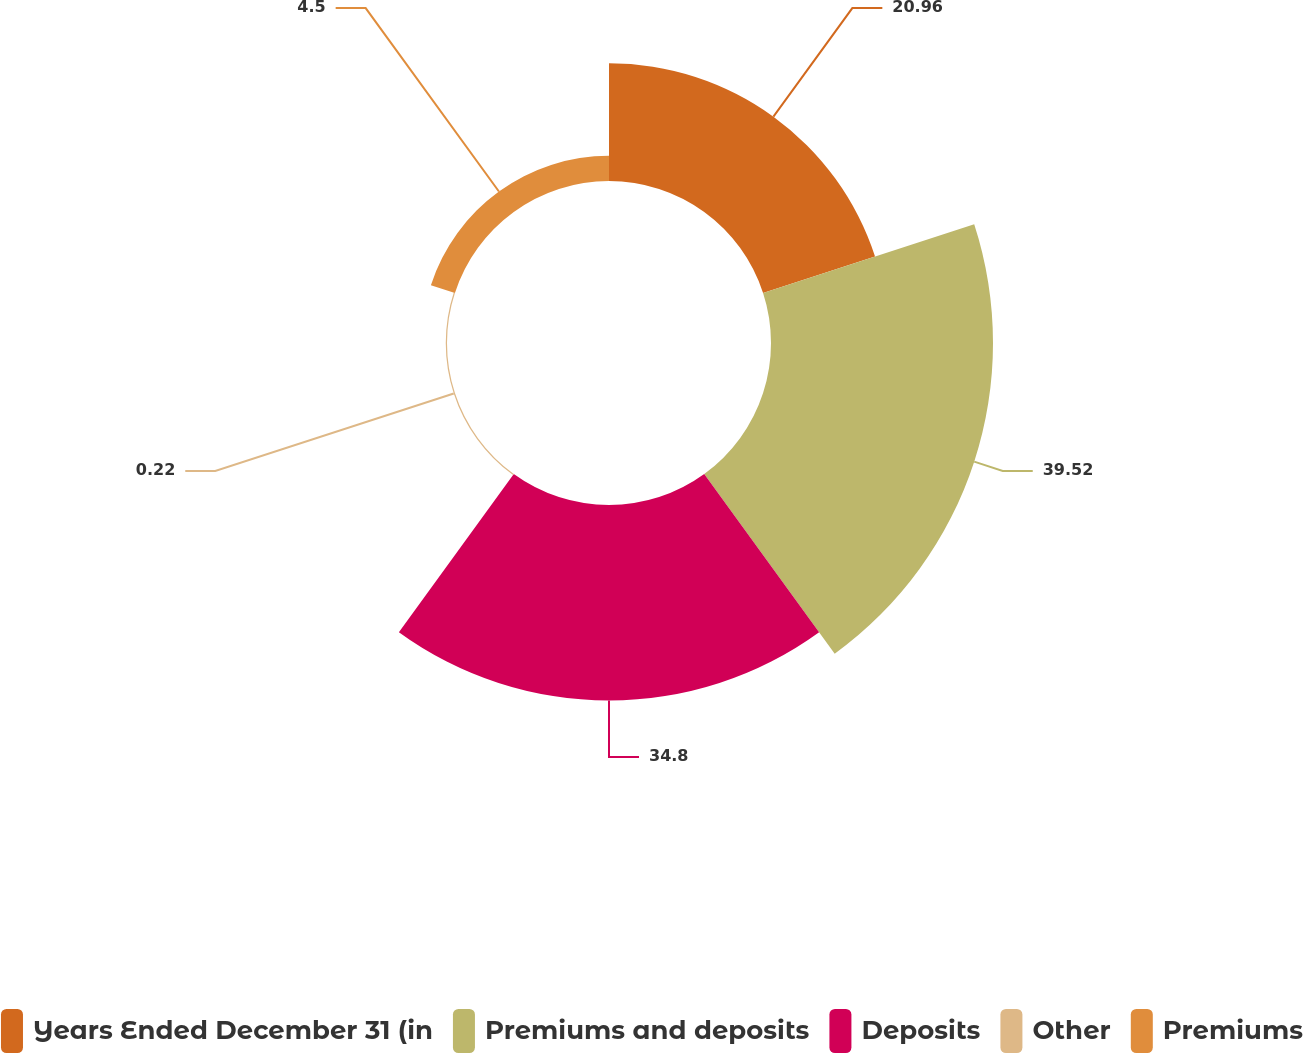Convert chart to OTSL. <chart><loc_0><loc_0><loc_500><loc_500><pie_chart><fcel>Years Ended December 31 (in<fcel>Premiums and deposits<fcel>Deposits<fcel>Other<fcel>Premiums<nl><fcel>20.96%<fcel>39.52%<fcel>34.8%<fcel>0.22%<fcel>4.5%<nl></chart> 